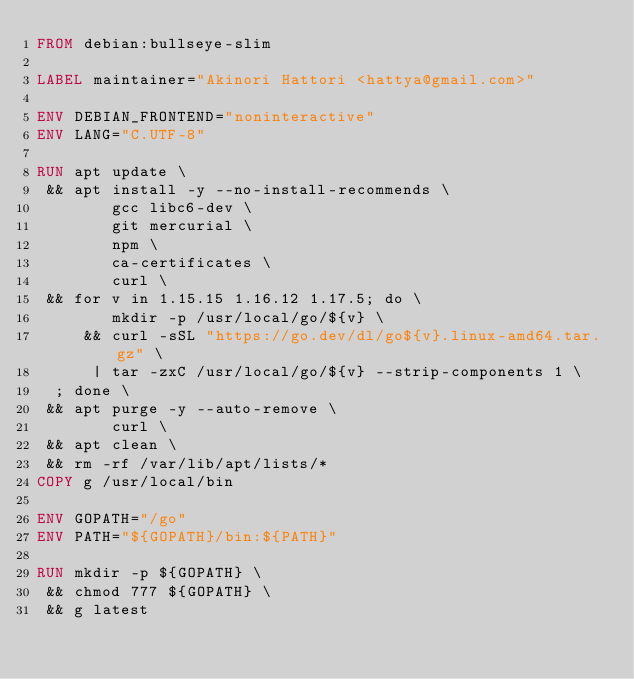Convert code to text. <code><loc_0><loc_0><loc_500><loc_500><_Dockerfile_>FROM debian:bullseye-slim

LABEL maintainer="Akinori Hattori <hattya@gmail.com>"

ENV DEBIAN_FRONTEND="noninteractive"
ENV LANG="C.UTF-8"

RUN apt update \
 && apt install -y --no-install-recommends \
        gcc libc6-dev \
        git mercurial \
        npm \
        ca-certificates \
        curl \
 && for v in 1.15.15 1.16.12 1.17.5; do \
        mkdir -p /usr/local/go/${v} \
     && curl -sSL "https://go.dev/dl/go${v}.linux-amd64.tar.gz" \
      | tar -zxC /usr/local/go/${v} --strip-components 1 \
  ; done \
 && apt purge -y --auto-remove \
        curl \
 && apt clean \
 && rm -rf /var/lib/apt/lists/*
COPY g /usr/local/bin

ENV GOPATH="/go"
ENV PATH="${GOPATH}/bin:${PATH}"

RUN mkdir -p ${GOPATH} \
 && chmod 777 ${GOPATH} \
 && g latest
</code> 